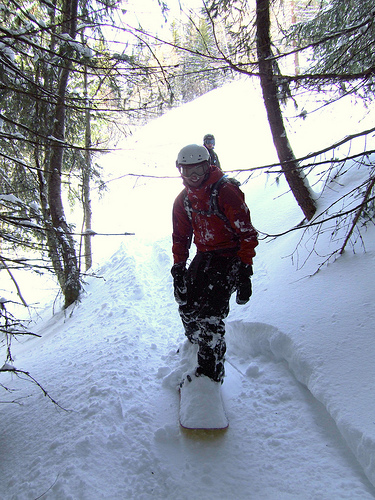<image>
Can you confirm if the helmet is on the snowboarder? No. The helmet is not positioned on the snowboarder. They may be near each other, but the helmet is not supported by or resting on top of the snowboarder. Where is the snowboard in relation to the snow? Is it under the snow? Yes. The snowboard is positioned underneath the snow, with the snow above it in the vertical space. Is there a people under the people? No. The people is not positioned under the people. The vertical relationship between these objects is different. 